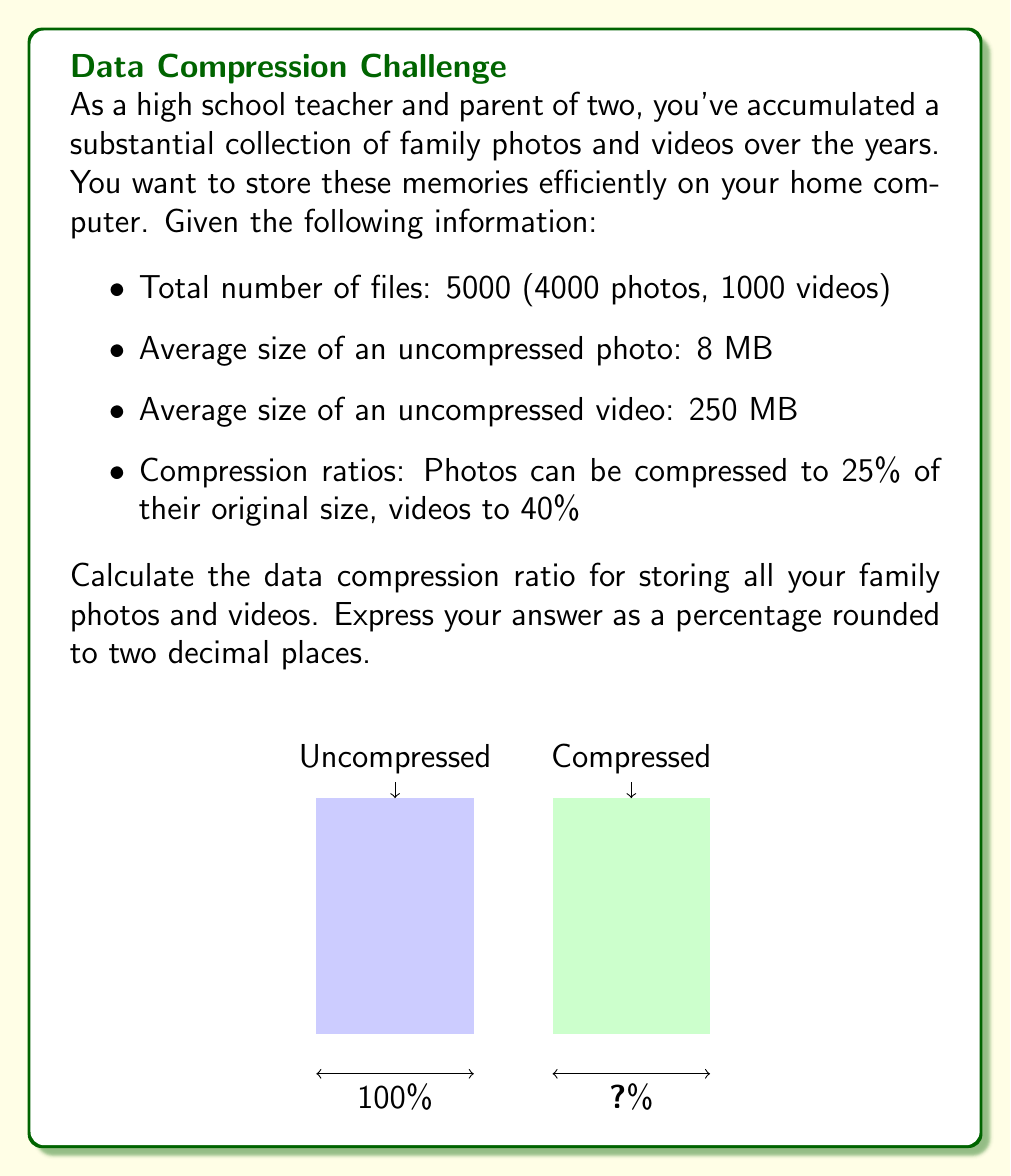Can you answer this question? Let's approach this step-by-step:

1) First, calculate the total uncompressed size:
   - Photos: $4000 \times 8 \text{ MB} = 32000 \text{ MB}$
   - Videos: $1000 \times 250 \text{ MB} = 250000 \text{ MB}$
   - Total: $32000 + 250000 = 282000 \text{ MB}$

2) Now, calculate the compressed size:
   - Photos: $32000 \text{ MB} \times 0.25 = 8000 \text{ MB}$
   - Videos: $250000 \text{ MB} \times 0.40 = 100000 \text{ MB}$
   - Total: $8000 + 100000 = 108000 \text{ MB}$

3) The compression ratio is the compressed size divided by the uncompressed size:

   $$\text{Compression Ratio} = \frac{\text{Compressed Size}}{\text{Uncompressed Size}} \times 100\%$$

   $$= \frac{108000}{282000} \times 100\% \approx 38.30\%$$

4) To get the percentage savings, subtract from 100%:

   $$\text{Savings} = 100\% - 38.30\% = 61.70\%$$

Therefore, the data compression ratio is 38.30%, meaning you can save 61.70% of storage space.
Answer: 38.30% 